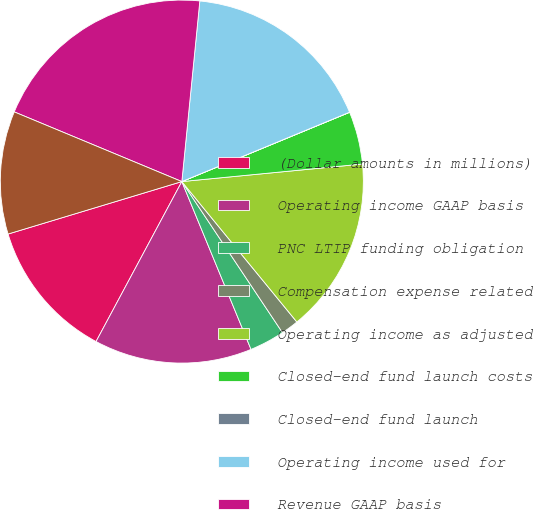<chart> <loc_0><loc_0><loc_500><loc_500><pie_chart><fcel>(Dollar amounts in millions)<fcel>Operating income GAAP basis<fcel>PNC LTIP funding obligation<fcel>Compensation expense related<fcel>Operating income as adjusted<fcel>Closed-end fund launch costs<fcel>Closed-end fund launch<fcel>Operating income used for<fcel>Revenue GAAP basis<fcel>Distribution and servicing<nl><fcel>12.5%<fcel>14.06%<fcel>3.13%<fcel>1.57%<fcel>15.62%<fcel>4.69%<fcel>0.01%<fcel>17.18%<fcel>20.31%<fcel>10.94%<nl></chart> 